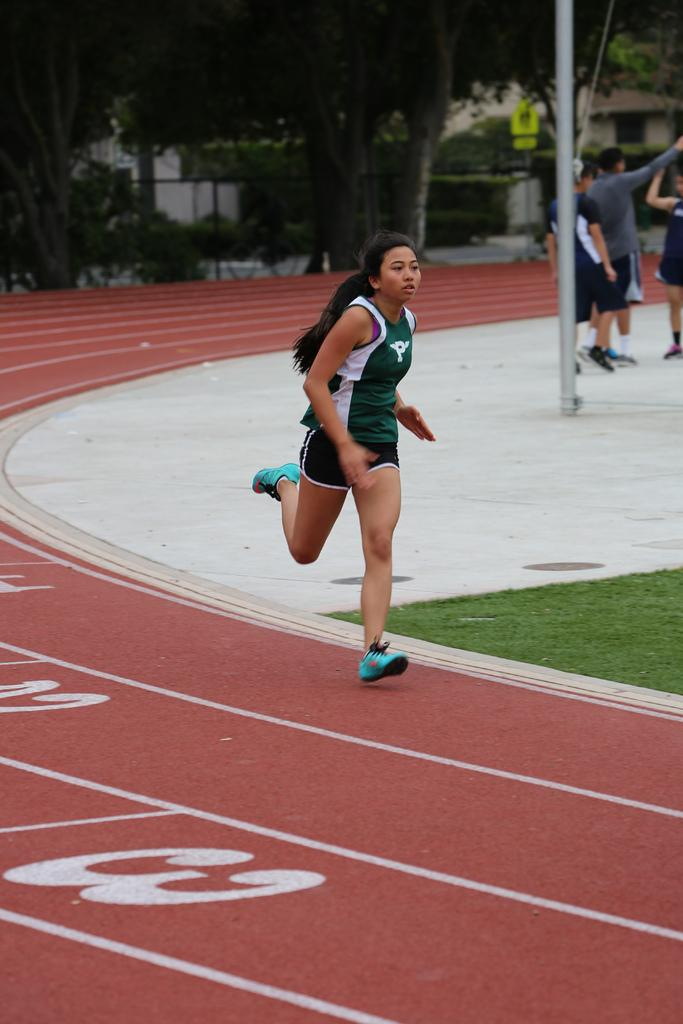Provide a one-sentence caption for the provided image. A track athlete is running on a sport track with the numbers 1, 2, and 3 in each lane. 